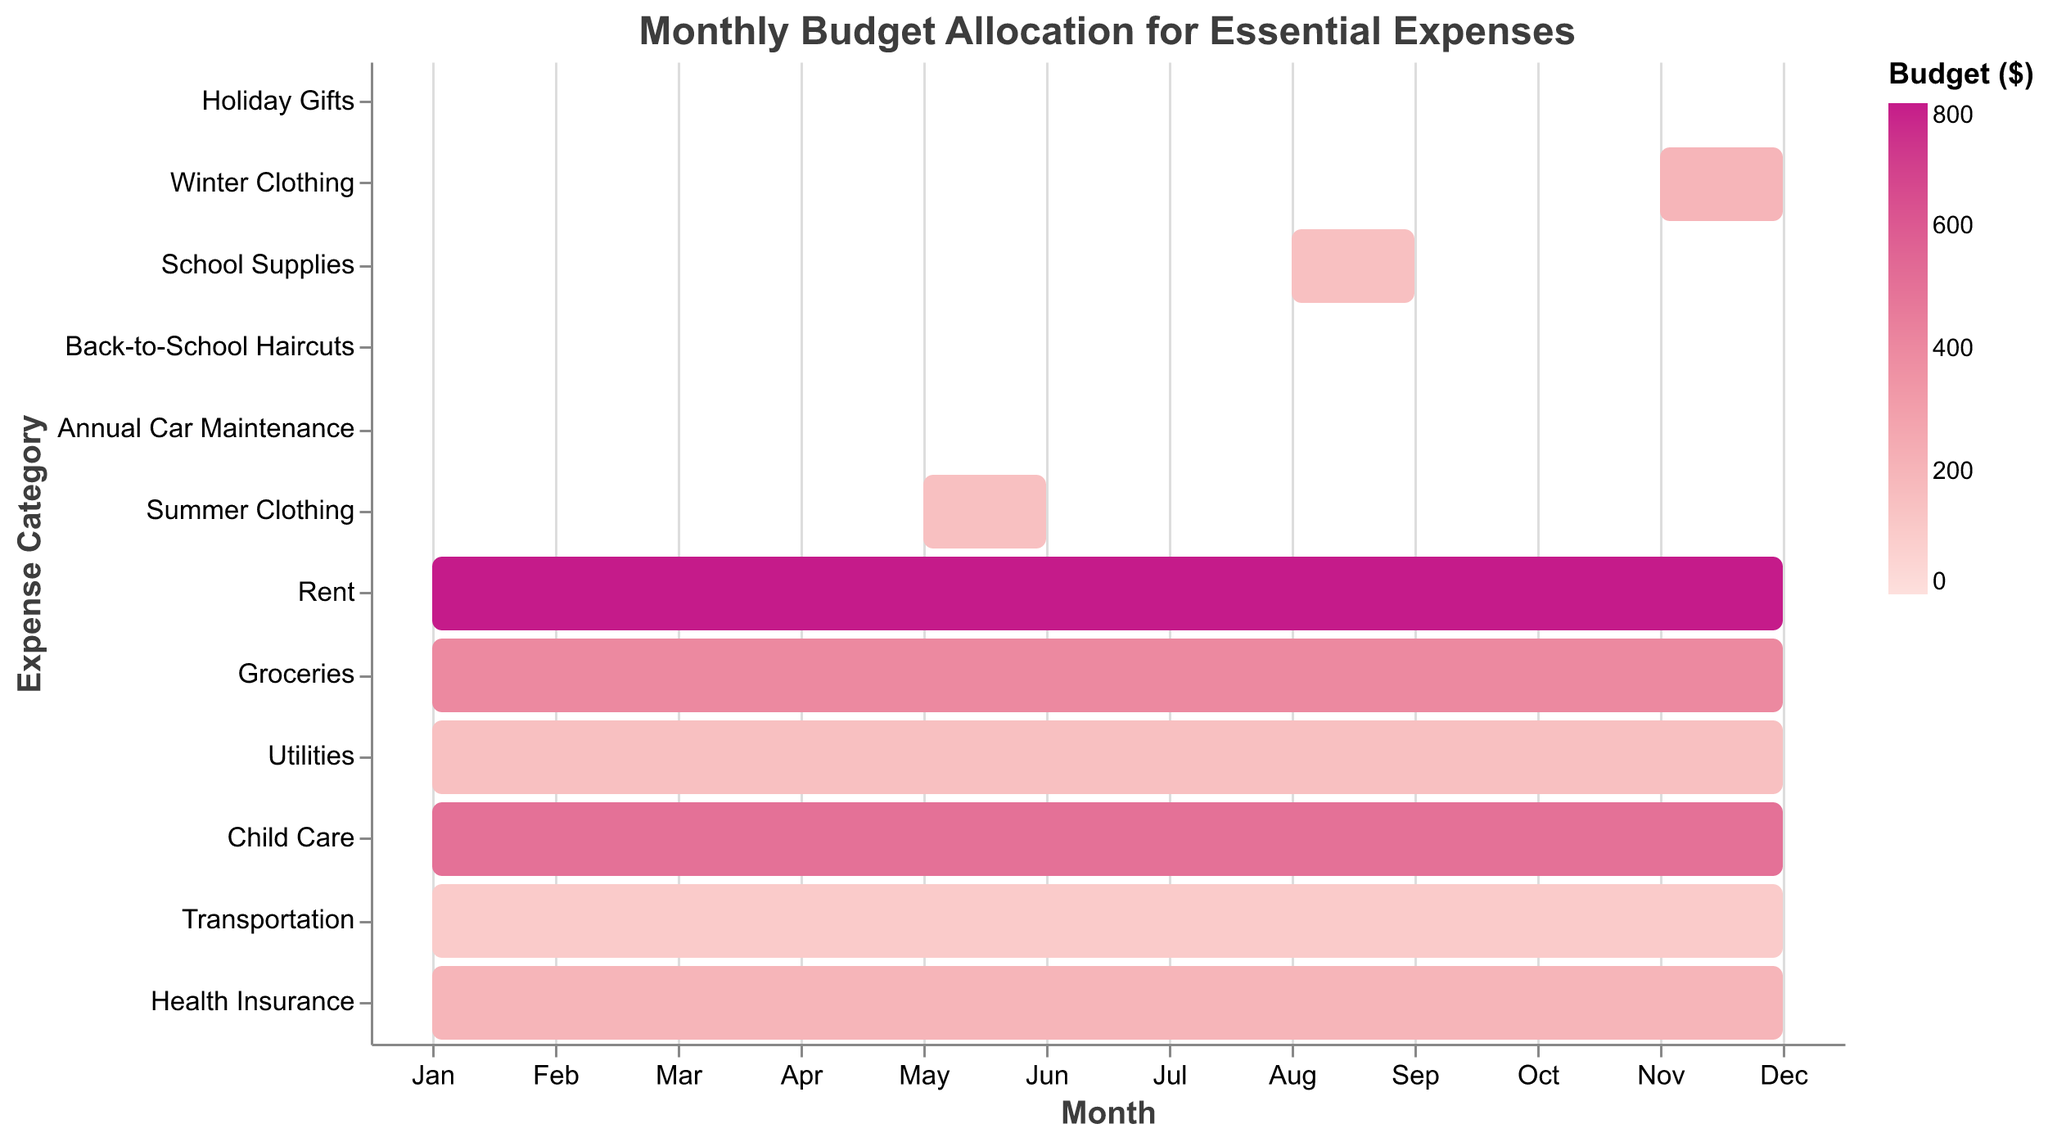What is the title of the chart? The title is located at the top and it generally gives an overview of what the chart is about. The title here is "Monthly Budget Allocation for Essential Expenses."
Answer: Monthly Budget Allocation for Essential Expenses Which expense category has the highest budget allocation? By examining the color intensity and the budget figures listed in the tooltip, "Rent" has the highest budget allocation of $800.
Answer: Rent Which months are budgeted for school supplies? The timeline bar for "School Supplies" spans from month 8 to month 9. This is confirmed by checking the data shown when hovering over the "School Supplies" bar.
Answer: August to September How many categories have expenses allocated for the entire year? Full-year expenses have bars that span from month 1 to month 12. These categories are Rent, Groceries, Utilities, Child Care, Transportation, and Health Insurance, totaling six full-year categories.
Answer: 6 What is the total budget allocated for clothing (both winter and summer)? Add the budget for "Winter Clothing" ($200) and "Summer Clothing" ($150). 200 + 150 = 350.
Answer: $350 Which expense category has the shortest allocation period, and how long is it? "Back-to-School Haircuts" has the shortest allocation period, assigned to only one month (August) as indicated by its start and end points being the same.
Answer: Back-to-School Haircuts, 1 month During which month is the budget allocation highest? By inspecting each budget allocation month by month, December has a high concentration of critical expenses such as Rent, Groceries, Utilities, Child Care, Transportation, Health Insurance, Winter Clothing, and Holiday Gifts. Summing up the budgets for these categories in December gives a clear idea.
Answer: December Compare the budget allocations for "Utilities" and "Transportation". Which one has a higher budget and by how much? "Utilities" has a $150 budget, while "Transportation" has $100. The difference is 150 - 100 = 50.
Answer: Utilities by $50 When is annual car maintenance scheduled, and what is its budget? The Gantt chart shows "Annual Car Maintenance" scheduled in month 6 (June) with a budget allocation of $300. This information is also visible by checking the bar for "Annual Car Maintenance."
Answer: June, $300 Which three expense categories have the lowest budget allocations? Reviewing the budget values, "Transportation" ($100), "Back-to-School Haircuts" ($50), and "Utilities" ($150) have the lowest allocations. By comparing these values directly, you notice that "Transportation" and "Utilities" only span the entirety of the year, while "Back-to-School Haircuts" span a single month.
Answer: Transportation ($100), Back-to-School Haircuts ($50), Utilities ($150) 